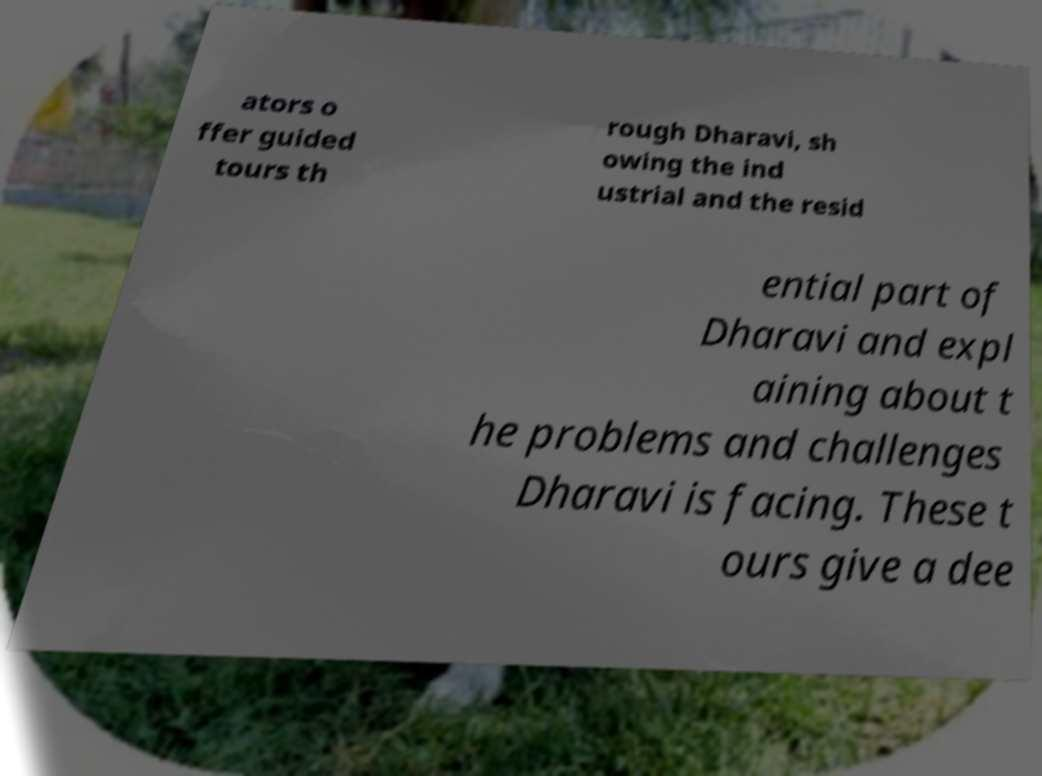I need the written content from this picture converted into text. Can you do that? ators o ffer guided tours th rough Dharavi, sh owing the ind ustrial and the resid ential part of Dharavi and expl aining about t he problems and challenges Dharavi is facing. These t ours give a dee 